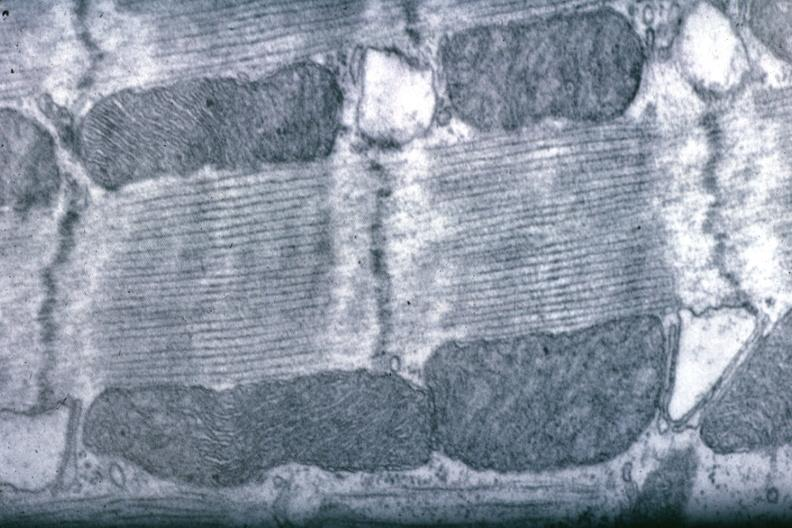what is present?
Answer the question using a single word or phrase. Myocardium 